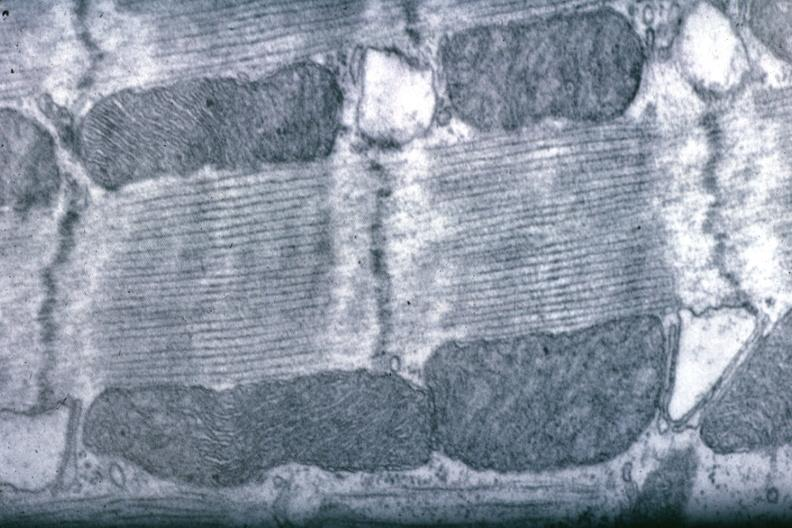what is present?
Answer the question using a single word or phrase. Myocardium 